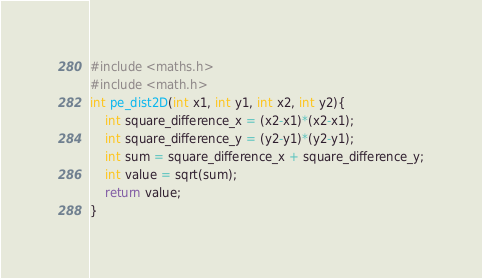Convert code to text. <code><loc_0><loc_0><loc_500><loc_500><_C_>#include <maths.h>
#include <math.h>
int pe_dist2D(int x1, int y1, int x2, int y2){
    int square_difference_x = (x2-x1)*(x2-x1);
    int square_difference_y = (y2-y1)*(y2-y1);
    int sum = square_difference_x + square_difference_y;
    int value = sqrt(sum);
    return value;
}</code> 